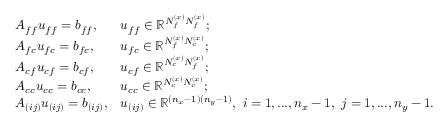<formula> <loc_0><loc_0><loc_500><loc_500>\begin{array} { l l } { A _ { f f } u _ { f f } = b _ { f f } , } & { u _ { f f } \in \mathbb { R } ^ { N _ { f } ^ { ( x ) } N _ { f } ^ { ( x ) } } ; } \\ { A _ { f c } u _ { f c } = b _ { f c } , } & { u _ { f c } \in \mathbb { R } ^ { N _ { f } ^ { ( x ) } N _ { c } ^ { ( x ) } } ; } \\ { A _ { c f } u _ { c f } = b _ { c f } , } & { u _ { c f } \in \mathbb { R } ^ { N _ { c } ^ { ( x ) } N _ { f } ^ { ( x ) } } ; } \\ { A _ { c c } u _ { c c } = b _ { c c } , } & { u _ { c c } \in \mathbb { R } ^ { N _ { c } ^ { ( x ) } N _ { c } ^ { ( x ) } } ; } \\ { A _ { ( i j ) } u _ { ( i j ) } = b _ { ( i j ) } , } & { u _ { ( i j ) } \in \mathbb { R } ^ { ( n _ { x } - 1 ) ( n _ { y } - 1 ) } , \ i = 1 , \dots , n _ { x } - 1 , \ j = 1 , \dots , n _ { y } - 1 . } \end{array}</formula> 